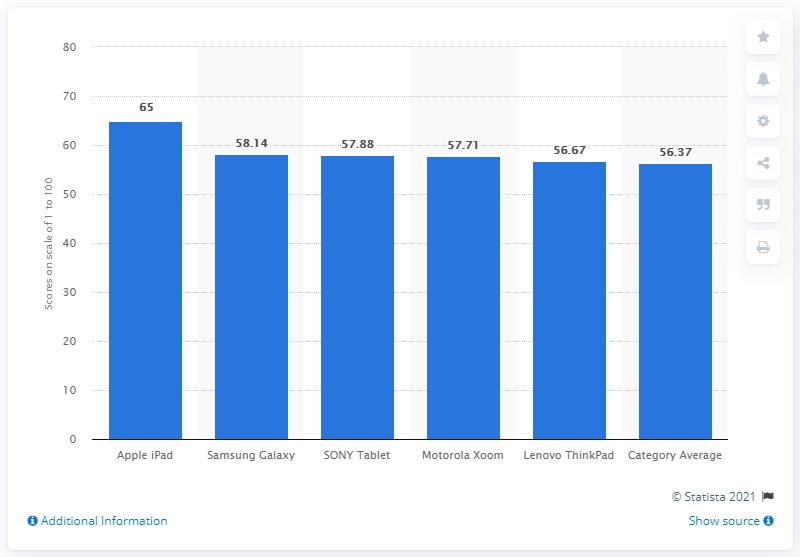List a handful of essential elements in this visual. In the EquiTrend survey, Samsung received a score of 58.14. 